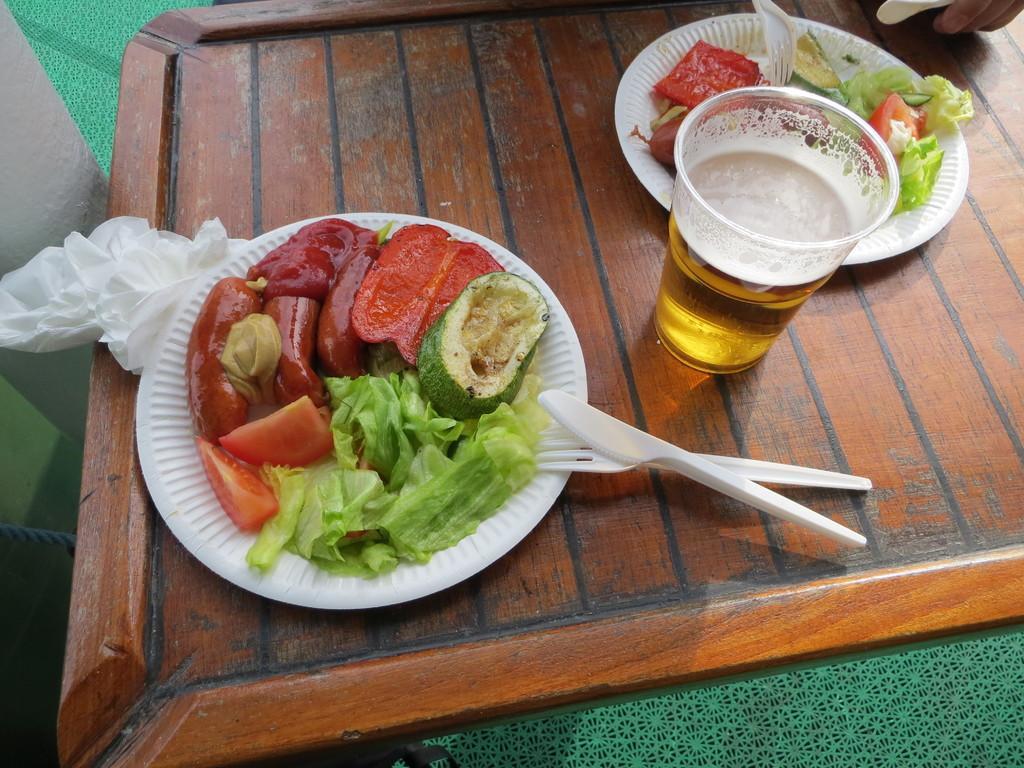Describe this image in one or two sentences. In this image I can see food items in the plates. I can see a spoon,fork and glass. They are on the brown tray. Food is in different color. 